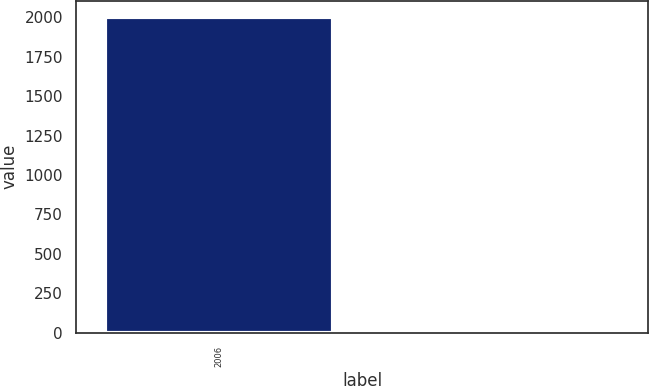Convert chart. <chart><loc_0><loc_0><loc_500><loc_500><bar_chart><fcel>2006<fcel>Unnamed: 1<nl><fcel>2005<fcel>13<nl></chart> 